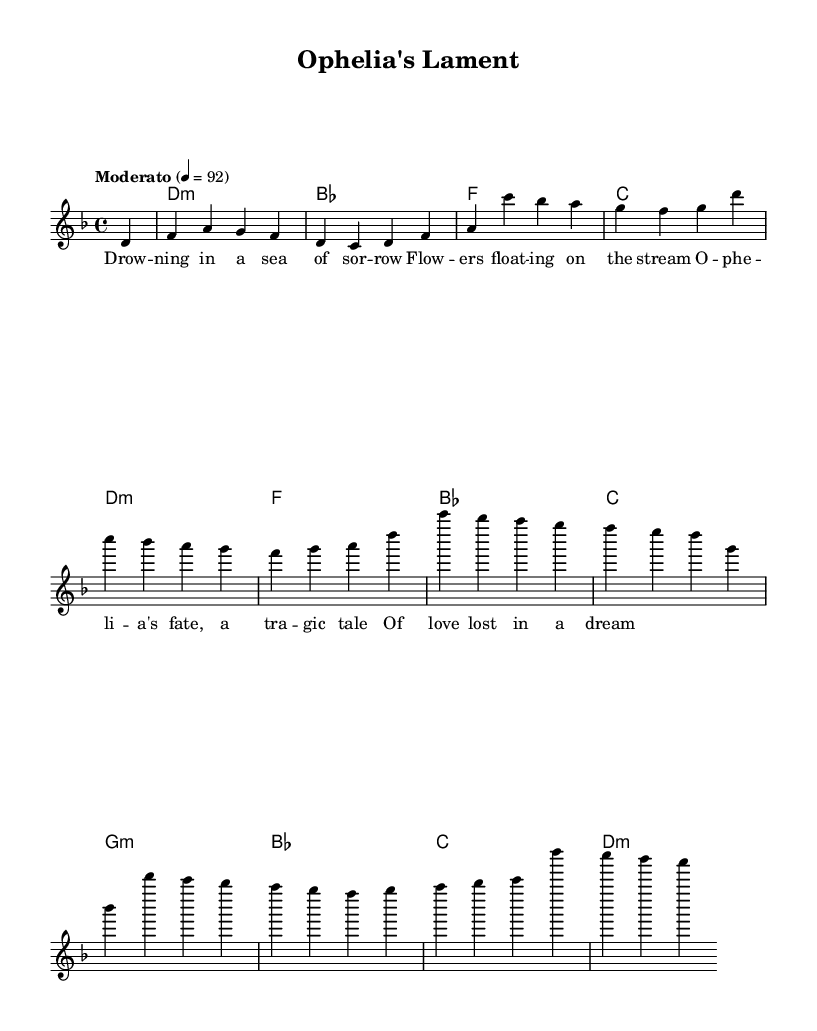What is the key signature of this music? The key signature indicates D minor, which has one flat (B flat). This can be identified from the key signature at the beginning of the staff.
Answer: D minor What is the time signature of this piece? The time signature shown at the beginning of the score is 4/4, which means there are four beats per measure. This is evident from the notation at the start of the music.
Answer: 4/4 What is the tempo marking of this ballad? The tempo marking is "Moderato," which suggests a moderate pace. This is indicated in the tempo indication at the beginning of the score.
Answer: Moderato How many measures are there in the melody? By counting the individual measures in the melody part, there are a total of 8 measures present in this section. Each measure is defined by vertical bar lines.
Answer: 8 What is the first chord in the harmonies? The first chord in the harmonies is a D minor chord, indicated by "d1:m" in the chord section at the beginning of the score.
Answer: D minor How do the lyrics describe Ophelia’s state of mind? The lyrics convey a sense of sorrow and tragedy, as they mention "Drowning in a sea of sorrow," reflecting emotional depth and loss. This is inferred from the line's content and thematic relevance to Ophelia's character in Shakespeare.
Answer: Sorrow What type of musical form is used in this ballad? The structure of the piece appears to follow a simple verse format, where lyrical content is matched with the melody and harmonies throughout the sections. This can be inferred from the arrangement of lyrics alongside the repeated melody and harmonies.
Answer: Verse 